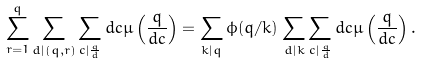<formula> <loc_0><loc_0><loc_500><loc_500>\sum _ { r = 1 } ^ { q } \sum _ { d | ( q , r ) } \sum _ { c | \frac { q } { d } } d c \mu \left ( \frac { q } { d c } \right ) = \sum _ { k | q } \phi ( q / k ) \sum _ { d | k } \sum _ { c | \frac { q } { d } } d c \mu \left ( \frac { q } { d c } \right ) .</formula> 